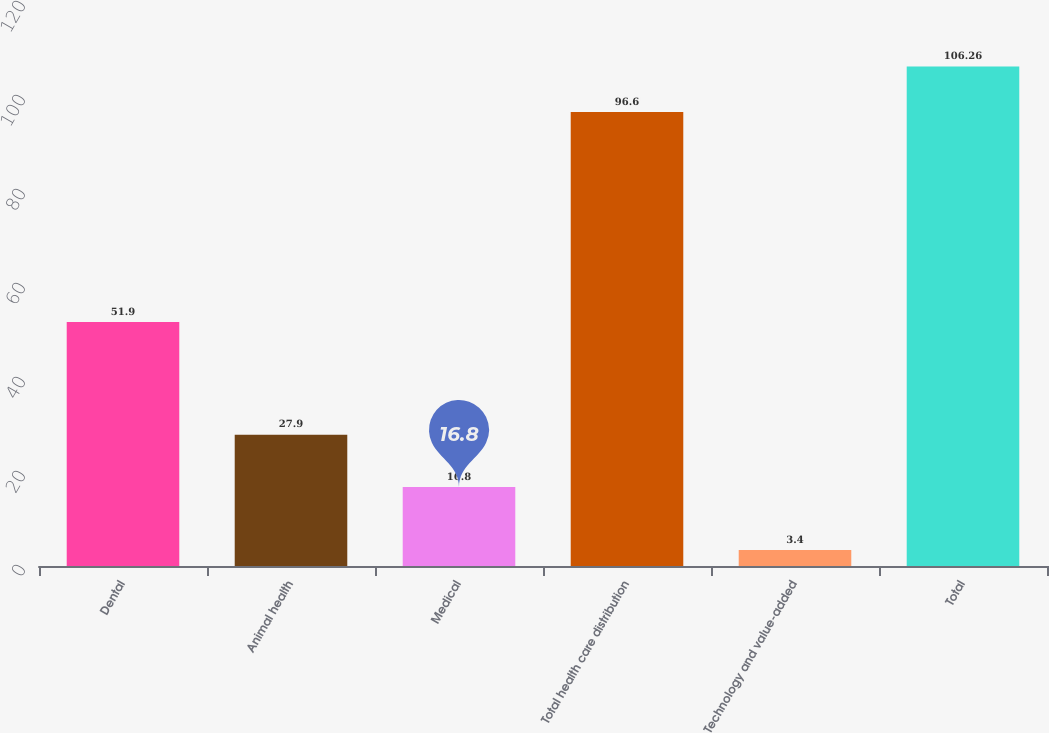<chart> <loc_0><loc_0><loc_500><loc_500><bar_chart><fcel>Dental<fcel>Animal health<fcel>Medical<fcel>Total health care distribution<fcel>Technology and value-added<fcel>Total<nl><fcel>51.9<fcel>27.9<fcel>16.8<fcel>96.6<fcel>3.4<fcel>106.26<nl></chart> 